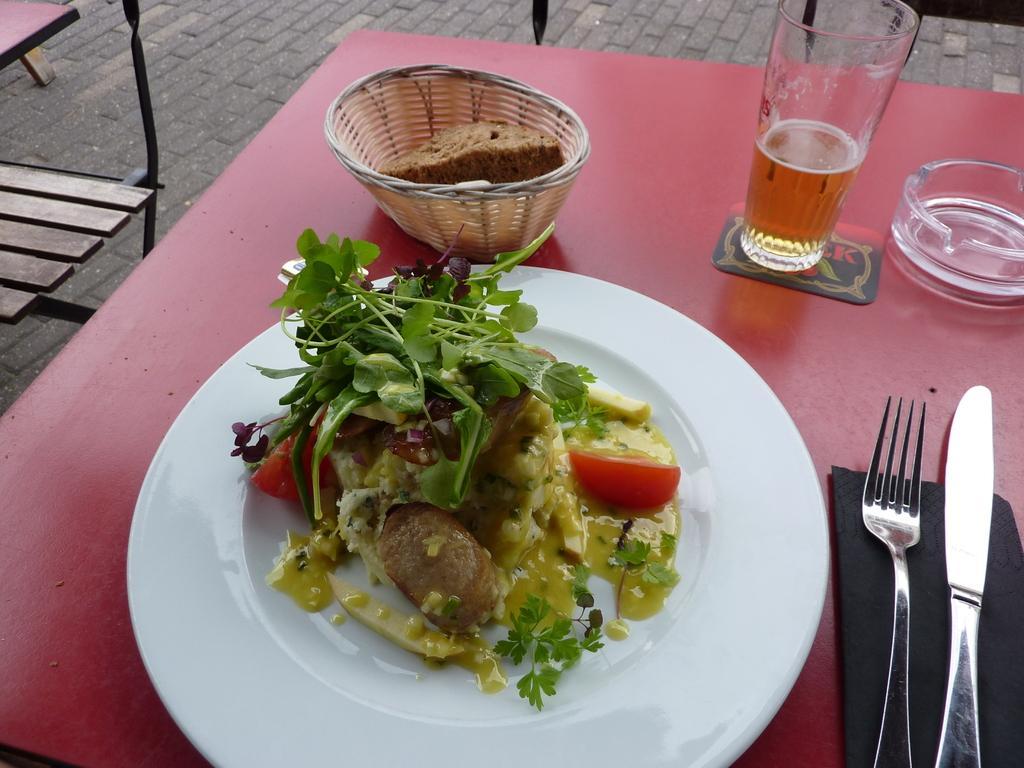Could you give a brief overview of what you see in this image? In this picture we can see a table in the front, we can see a plate, a basket, a glass of drink, a cloth, a knife and a fork on this table, there is some food in this plate and basket, it looks like a bench on the left side. 